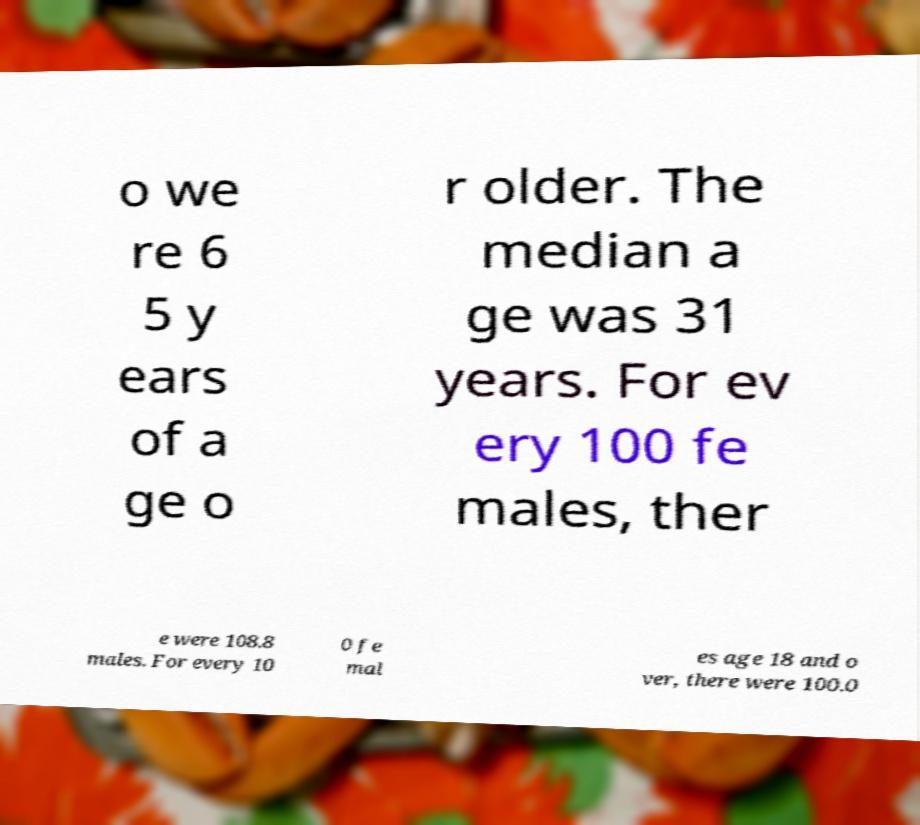I need the written content from this picture converted into text. Can you do that? o we re 6 5 y ears of a ge o r older. The median a ge was 31 years. For ev ery 100 fe males, ther e were 108.8 males. For every 10 0 fe mal es age 18 and o ver, there were 100.0 